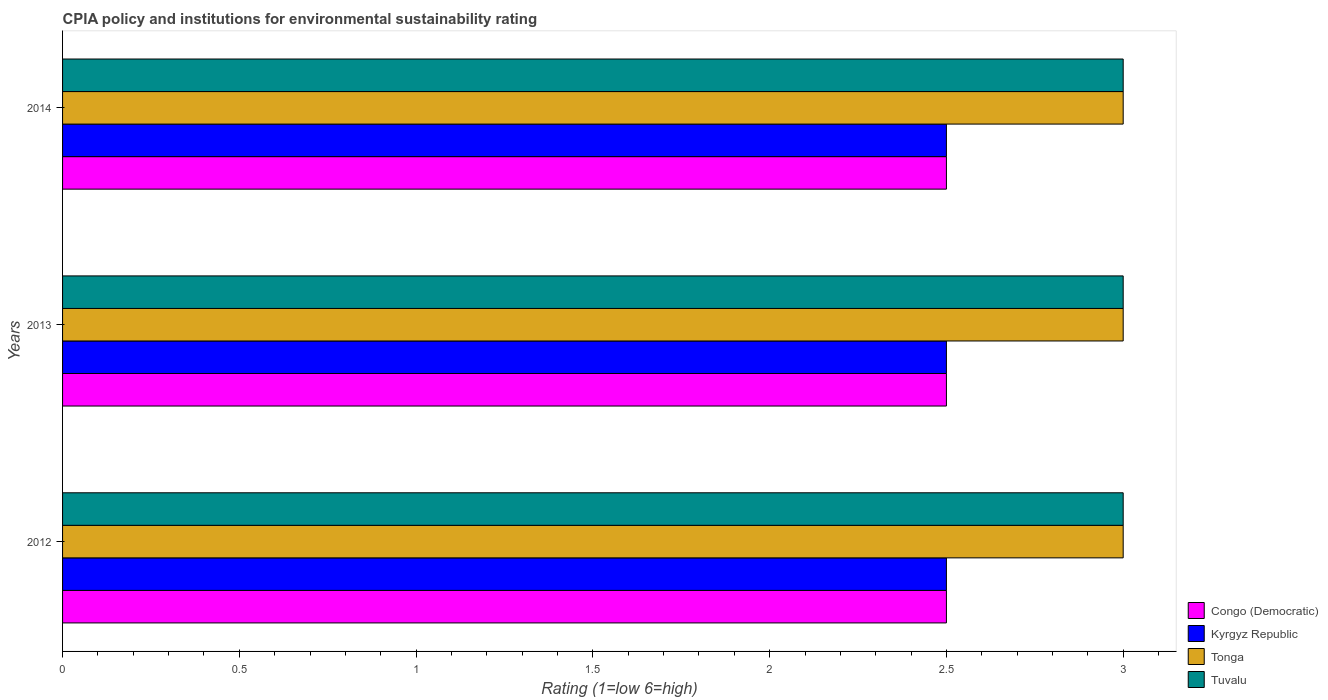How many bars are there on the 1st tick from the top?
Offer a terse response. 4. How many bars are there on the 1st tick from the bottom?
Offer a very short reply. 4. What is the label of the 3rd group of bars from the top?
Make the answer very short. 2012. What is the CPIA rating in Tuvalu in 2014?
Provide a short and direct response. 3. Across all years, what is the minimum CPIA rating in Congo (Democratic)?
Give a very brief answer. 2.5. What is the total CPIA rating in Tonga in the graph?
Give a very brief answer. 9. What is the difference between the CPIA rating in Kyrgyz Republic in 2013 and that in 2014?
Provide a short and direct response. 0. Is the CPIA rating in Tuvalu in 2013 less than that in 2014?
Offer a terse response. No. What is the difference between the highest and the second highest CPIA rating in Congo (Democratic)?
Give a very brief answer. 0. In how many years, is the CPIA rating in Tonga greater than the average CPIA rating in Tonga taken over all years?
Your response must be concise. 0. Is the sum of the CPIA rating in Tuvalu in 2012 and 2013 greater than the maximum CPIA rating in Tonga across all years?
Make the answer very short. Yes. Is it the case that in every year, the sum of the CPIA rating in Kyrgyz Republic and CPIA rating in Tuvalu is greater than the sum of CPIA rating in Congo (Democratic) and CPIA rating in Tonga?
Provide a succinct answer. No. What does the 2nd bar from the top in 2014 represents?
Give a very brief answer. Tonga. What does the 2nd bar from the bottom in 2013 represents?
Offer a terse response. Kyrgyz Republic. Is it the case that in every year, the sum of the CPIA rating in Kyrgyz Republic and CPIA rating in Tonga is greater than the CPIA rating in Tuvalu?
Offer a terse response. Yes. How many bars are there?
Make the answer very short. 12. Are all the bars in the graph horizontal?
Make the answer very short. Yes. How many years are there in the graph?
Provide a succinct answer. 3. What is the difference between two consecutive major ticks on the X-axis?
Your response must be concise. 0.5. Are the values on the major ticks of X-axis written in scientific E-notation?
Your answer should be compact. No. What is the title of the graph?
Ensure brevity in your answer.  CPIA policy and institutions for environmental sustainability rating. What is the Rating (1=low 6=high) of Congo (Democratic) in 2012?
Provide a short and direct response. 2.5. What is the Rating (1=low 6=high) in Congo (Democratic) in 2013?
Your answer should be compact. 2.5. What is the Rating (1=low 6=high) of Kyrgyz Republic in 2013?
Offer a terse response. 2.5. What is the Rating (1=low 6=high) in Tonga in 2013?
Your answer should be very brief. 3. What is the Rating (1=low 6=high) of Kyrgyz Republic in 2014?
Ensure brevity in your answer.  2.5. What is the Rating (1=low 6=high) in Tonga in 2014?
Give a very brief answer. 3. Across all years, what is the maximum Rating (1=low 6=high) of Kyrgyz Republic?
Ensure brevity in your answer.  2.5. Across all years, what is the maximum Rating (1=low 6=high) of Tonga?
Give a very brief answer. 3. Across all years, what is the maximum Rating (1=low 6=high) of Tuvalu?
Keep it short and to the point. 3. Across all years, what is the minimum Rating (1=low 6=high) of Congo (Democratic)?
Ensure brevity in your answer.  2.5. Across all years, what is the minimum Rating (1=low 6=high) of Kyrgyz Republic?
Your answer should be compact. 2.5. Across all years, what is the minimum Rating (1=low 6=high) in Tuvalu?
Your response must be concise. 3. What is the total Rating (1=low 6=high) in Congo (Democratic) in the graph?
Keep it short and to the point. 7.5. What is the total Rating (1=low 6=high) in Kyrgyz Republic in the graph?
Provide a short and direct response. 7.5. What is the difference between the Rating (1=low 6=high) in Congo (Democratic) in 2012 and that in 2013?
Give a very brief answer. 0. What is the difference between the Rating (1=low 6=high) in Kyrgyz Republic in 2012 and that in 2013?
Ensure brevity in your answer.  0. What is the difference between the Rating (1=low 6=high) of Tuvalu in 2012 and that in 2013?
Provide a succinct answer. 0. What is the difference between the Rating (1=low 6=high) in Congo (Democratic) in 2012 and that in 2014?
Your answer should be compact. 0. What is the difference between the Rating (1=low 6=high) in Kyrgyz Republic in 2012 and that in 2014?
Your answer should be compact. 0. What is the difference between the Rating (1=low 6=high) in Tonga in 2012 and that in 2014?
Your answer should be very brief. 0. What is the difference between the Rating (1=low 6=high) of Tuvalu in 2012 and that in 2014?
Offer a very short reply. 0. What is the difference between the Rating (1=low 6=high) in Tuvalu in 2013 and that in 2014?
Provide a succinct answer. 0. What is the difference between the Rating (1=low 6=high) of Kyrgyz Republic in 2012 and the Rating (1=low 6=high) of Tonga in 2013?
Give a very brief answer. -0.5. What is the difference between the Rating (1=low 6=high) in Kyrgyz Republic in 2012 and the Rating (1=low 6=high) in Tuvalu in 2013?
Your answer should be very brief. -0.5. What is the difference between the Rating (1=low 6=high) of Tonga in 2012 and the Rating (1=low 6=high) of Tuvalu in 2013?
Offer a very short reply. 0. What is the difference between the Rating (1=low 6=high) in Congo (Democratic) in 2012 and the Rating (1=low 6=high) in Kyrgyz Republic in 2014?
Your answer should be very brief. 0. What is the difference between the Rating (1=low 6=high) of Kyrgyz Republic in 2012 and the Rating (1=low 6=high) of Tonga in 2014?
Ensure brevity in your answer.  -0.5. What is the difference between the Rating (1=low 6=high) of Tonga in 2012 and the Rating (1=low 6=high) of Tuvalu in 2014?
Give a very brief answer. 0. What is the difference between the Rating (1=low 6=high) of Congo (Democratic) in 2013 and the Rating (1=low 6=high) of Tonga in 2014?
Provide a succinct answer. -0.5. What is the difference between the Rating (1=low 6=high) in Kyrgyz Republic in 2013 and the Rating (1=low 6=high) in Tonga in 2014?
Offer a very short reply. -0.5. What is the difference between the Rating (1=low 6=high) of Kyrgyz Republic in 2013 and the Rating (1=low 6=high) of Tuvalu in 2014?
Keep it short and to the point. -0.5. What is the difference between the Rating (1=low 6=high) of Tonga in 2013 and the Rating (1=low 6=high) of Tuvalu in 2014?
Your answer should be compact. 0. What is the average Rating (1=low 6=high) of Congo (Democratic) per year?
Ensure brevity in your answer.  2.5. What is the average Rating (1=low 6=high) of Tuvalu per year?
Make the answer very short. 3. In the year 2012, what is the difference between the Rating (1=low 6=high) of Congo (Democratic) and Rating (1=low 6=high) of Tonga?
Provide a succinct answer. -0.5. In the year 2012, what is the difference between the Rating (1=low 6=high) in Kyrgyz Republic and Rating (1=low 6=high) in Tonga?
Your answer should be compact. -0.5. In the year 2012, what is the difference between the Rating (1=low 6=high) of Tonga and Rating (1=low 6=high) of Tuvalu?
Provide a short and direct response. 0. In the year 2013, what is the difference between the Rating (1=low 6=high) of Congo (Democratic) and Rating (1=low 6=high) of Kyrgyz Republic?
Your response must be concise. 0. In the year 2013, what is the difference between the Rating (1=low 6=high) of Kyrgyz Republic and Rating (1=low 6=high) of Tuvalu?
Offer a very short reply. -0.5. In the year 2013, what is the difference between the Rating (1=low 6=high) in Tonga and Rating (1=low 6=high) in Tuvalu?
Give a very brief answer. 0. In the year 2014, what is the difference between the Rating (1=low 6=high) of Congo (Democratic) and Rating (1=low 6=high) of Kyrgyz Republic?
Ensure brevity in your answer.  0. In the year 2014, what is the difference between the Rating (1=low 6=high) of Congo (Democratic) and Rating (1=low 6=high) of Tonga?
Keep it short and to the point. -0.5. In the year 2014, what is the difference between the Rating (1=low 6=high) in Congo (Democratic) and Rating (1=low 6=high) in Tuvalu?
Make the answer very short. -0.5. In the year 2014, what is the difference between the Rating (1=low 6=high) in Kyrgyz Republic and Rating (1=low 6=high) in Tonga?
Provide a short and direct response. -0.5. What is the ratio of the Rating (1=low 6=high) of Kyrgyz Republic in 2012 to that in 2013?
Provide a succinct answer. 1. What is the ratio of the Rating (1=low 6=high) of Congo (Democratic) in 2012 to that in 2014?
Offer a very short reply. 1. What is the ratio of the Rating (1=low 6=high) of Kyrgyz Republic in 2012 to that in 2014?
Your answer should be compact. 1. What is the ratio of the Rating (1=low 6=high) of Tuvalu in 2012 to that in 2014?
Give a very brief answer. 1. What is the ratio of the Rating (1=low 6=high) of Congo (Democratic) in 2013 to that in 2014?
Offer a very short reply. 1. What is the ratio of the Rating (1=low 6=high) in Tuvalu in 2013 to that in 2014?
Keep it short and to the point. 1. What is the difference between the highest and the lowest Rating (1=low 6=high) of Tonga?
Keep it short and to the point. 0. 